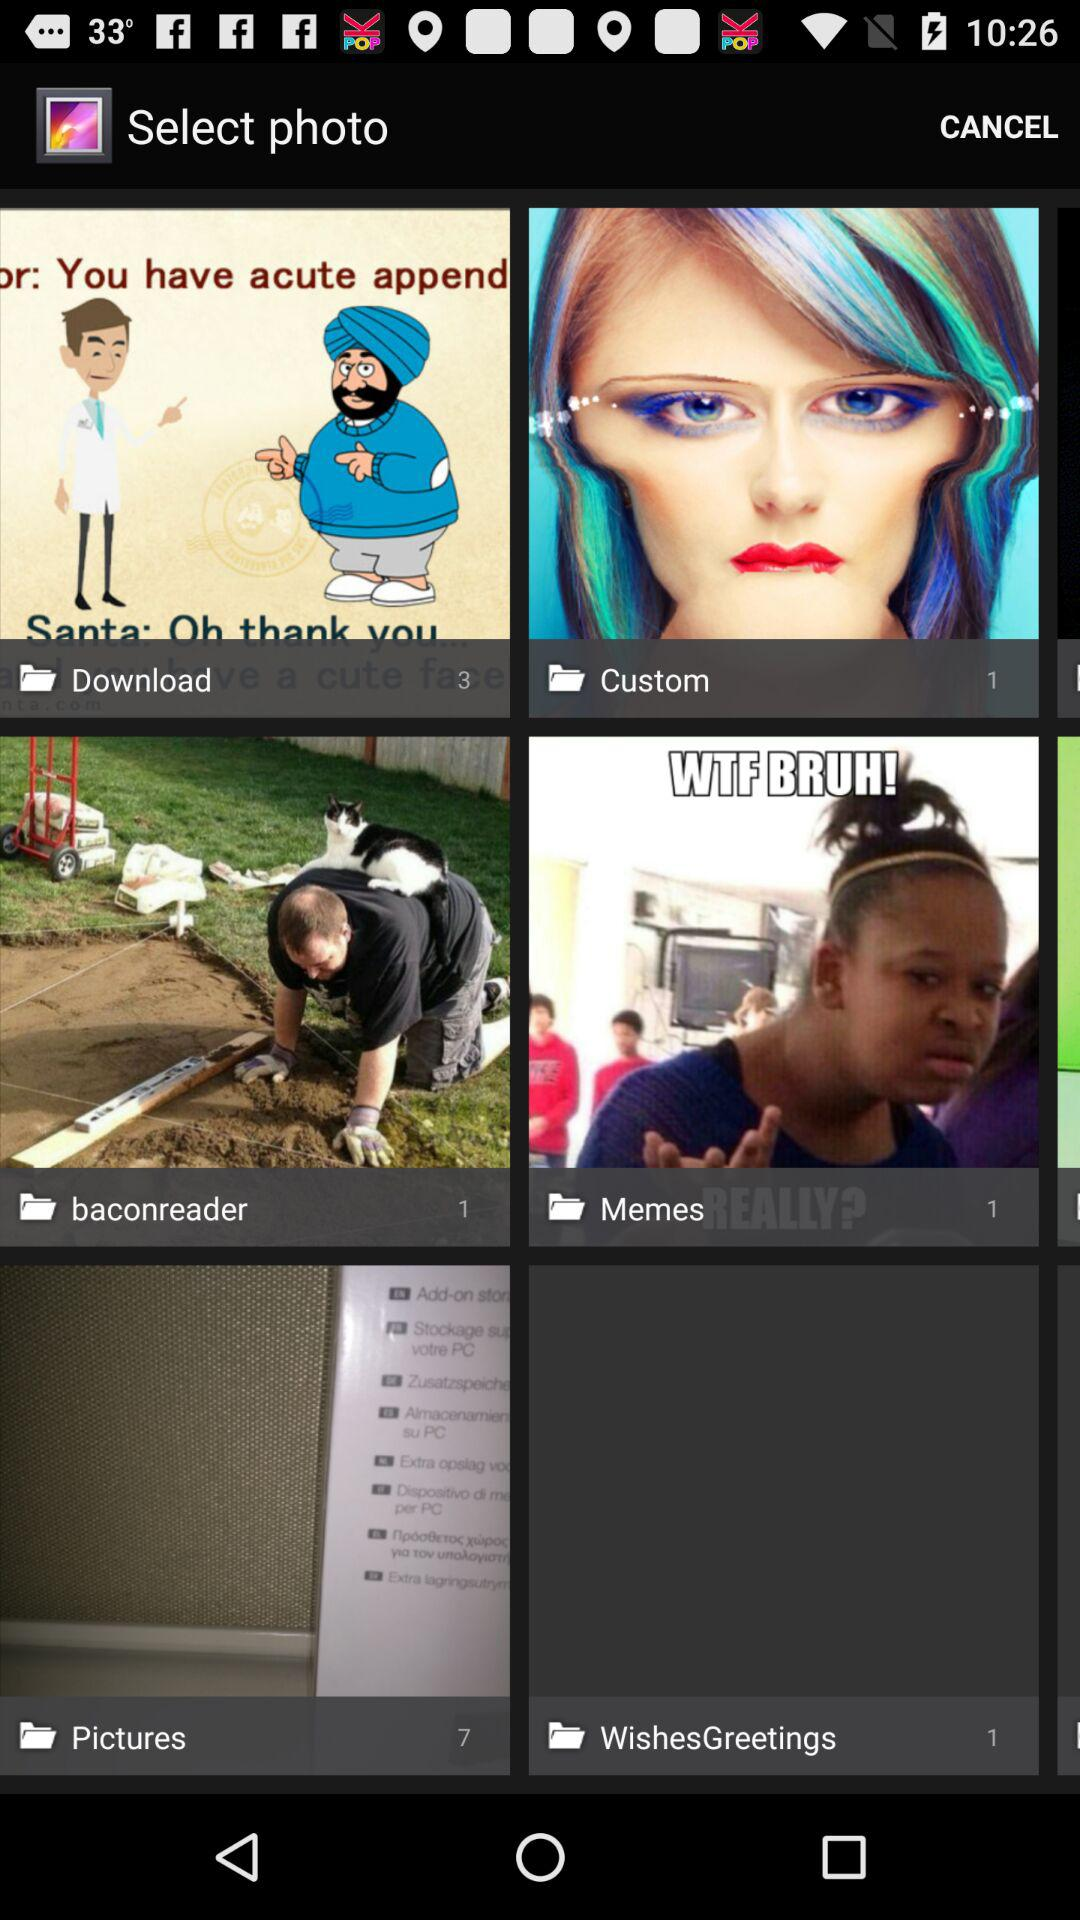What is the number of images in the picture folder? The number of images in the picture folder is 7. 